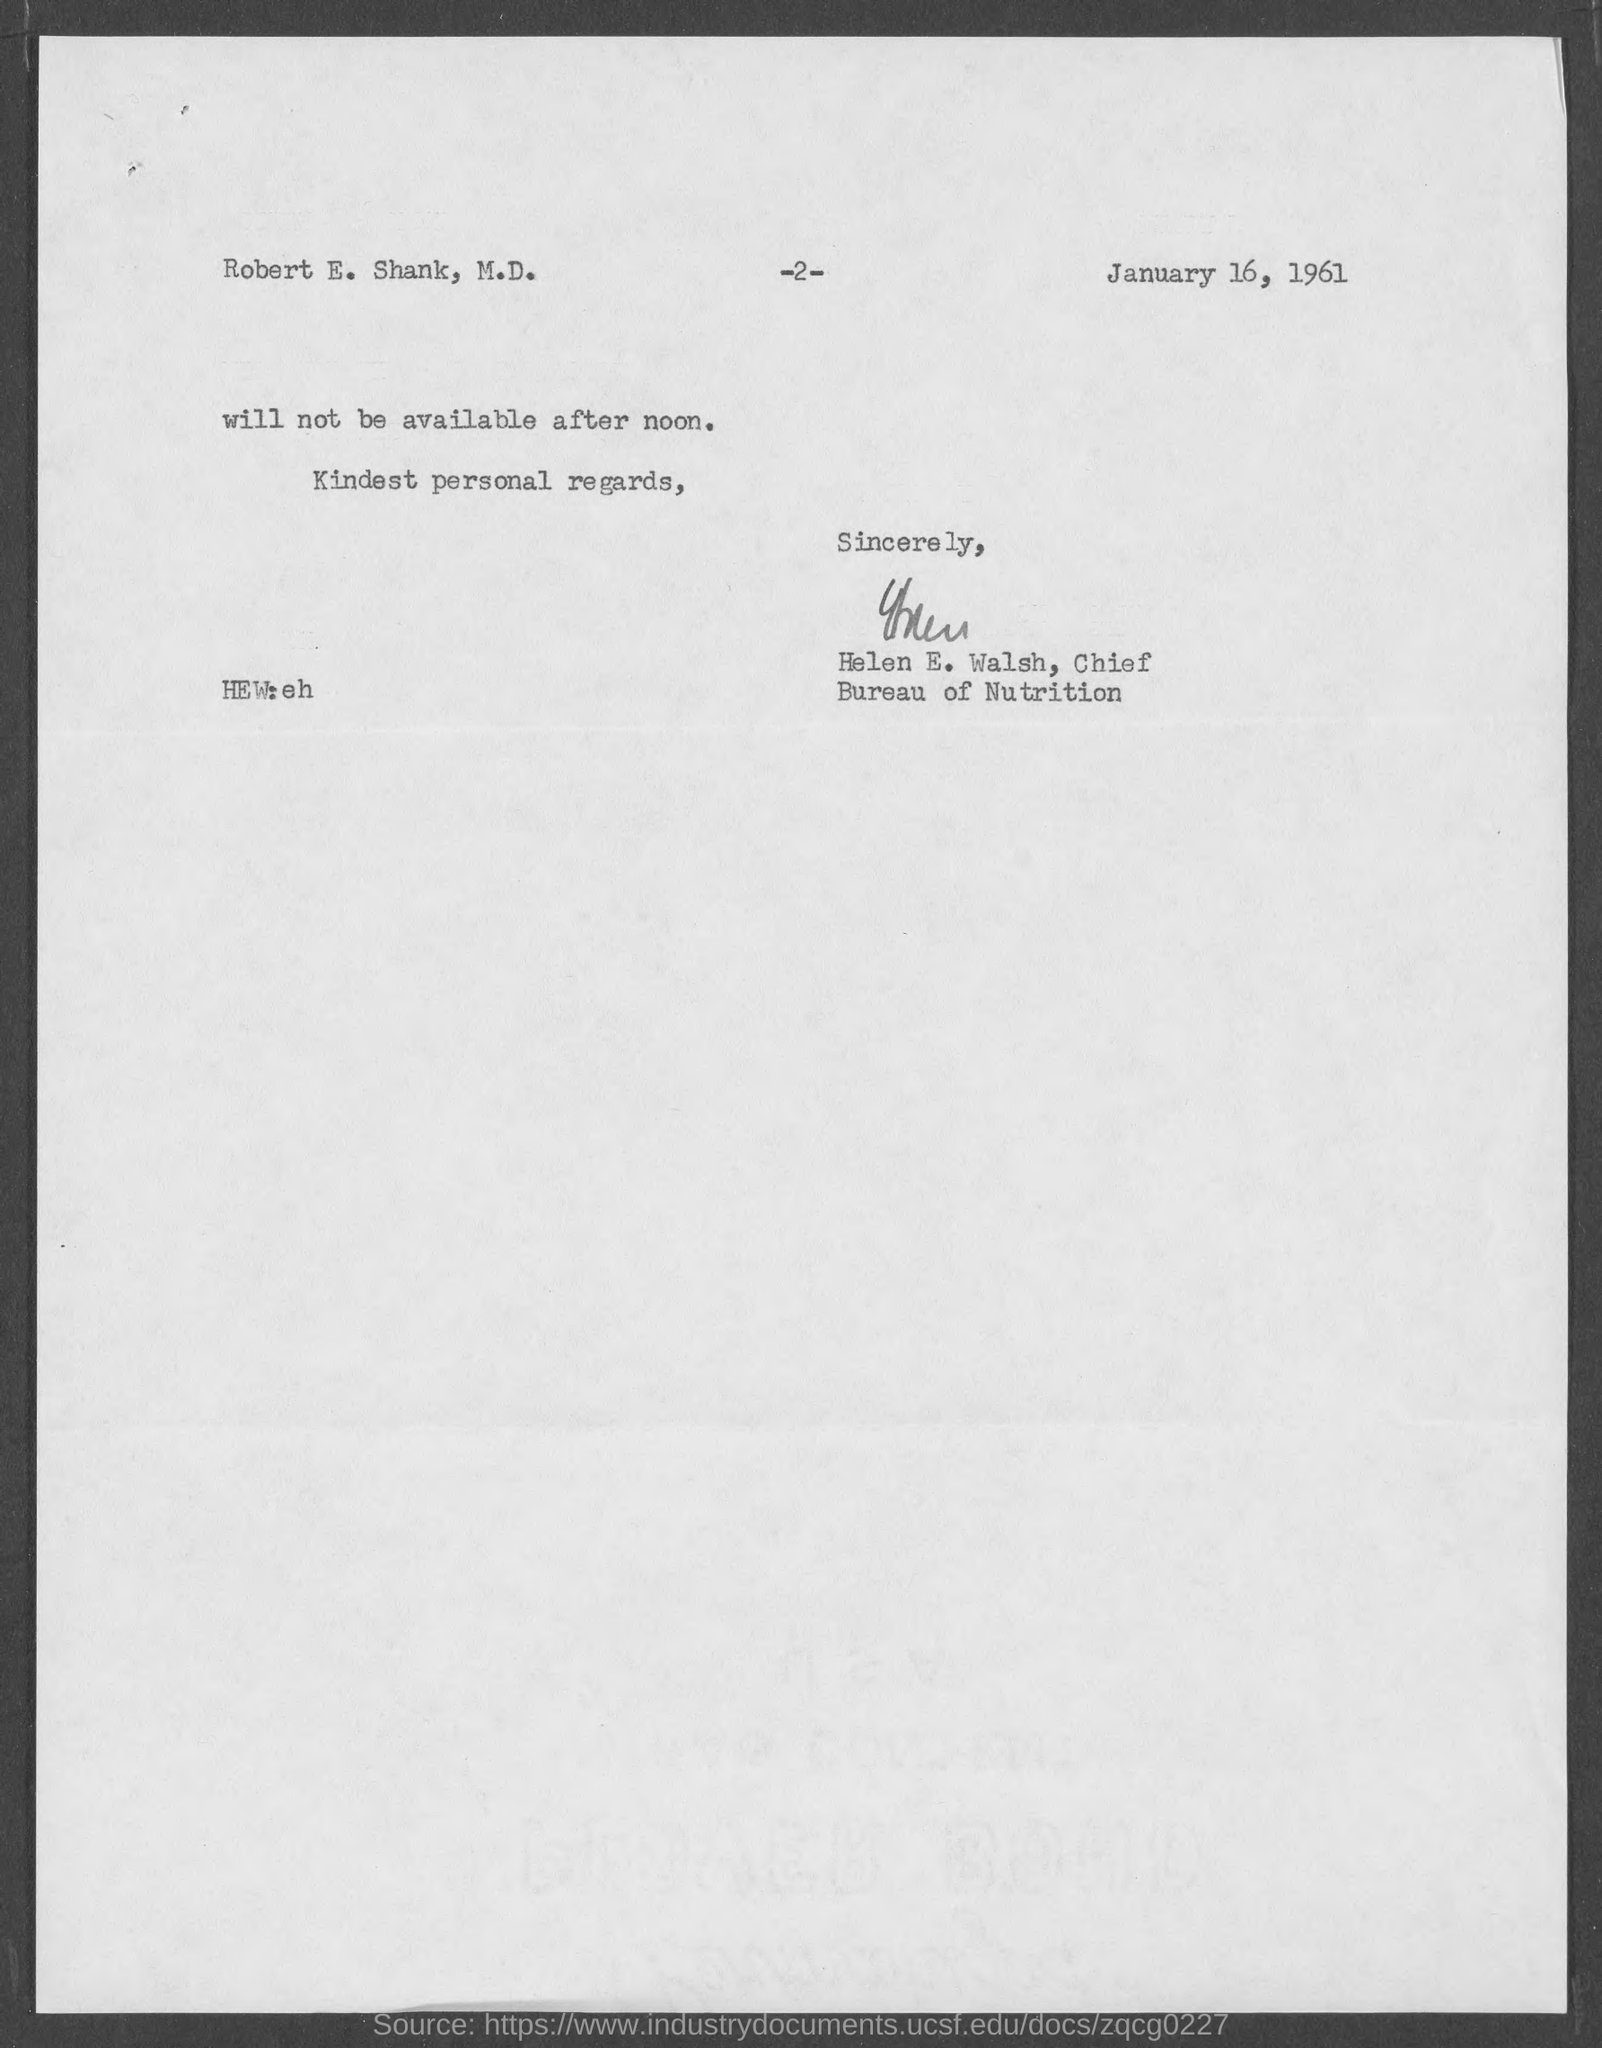Highlight a few significant elements in this photo. The letter is from Helen E. Walsh, who is the Chief... The date in the document is January 16, 1961. This letter is addressed to Robert E. Shank, M.D. 